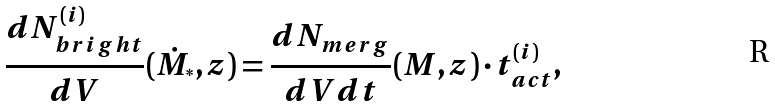Convert formula to latex. <formula><loc_0><loc_0><loc_500><loc_500>\frac { d N _ { b r i g h t } ^ { ( i ) } } { d V } ( \dot { M } _ { ^ { * } } , z ) = \frac { d N _ { m e r g } } { d V d t } ( M , z ) \cdot t _ { a c t } ^ { ( i ) } ,</formula> 